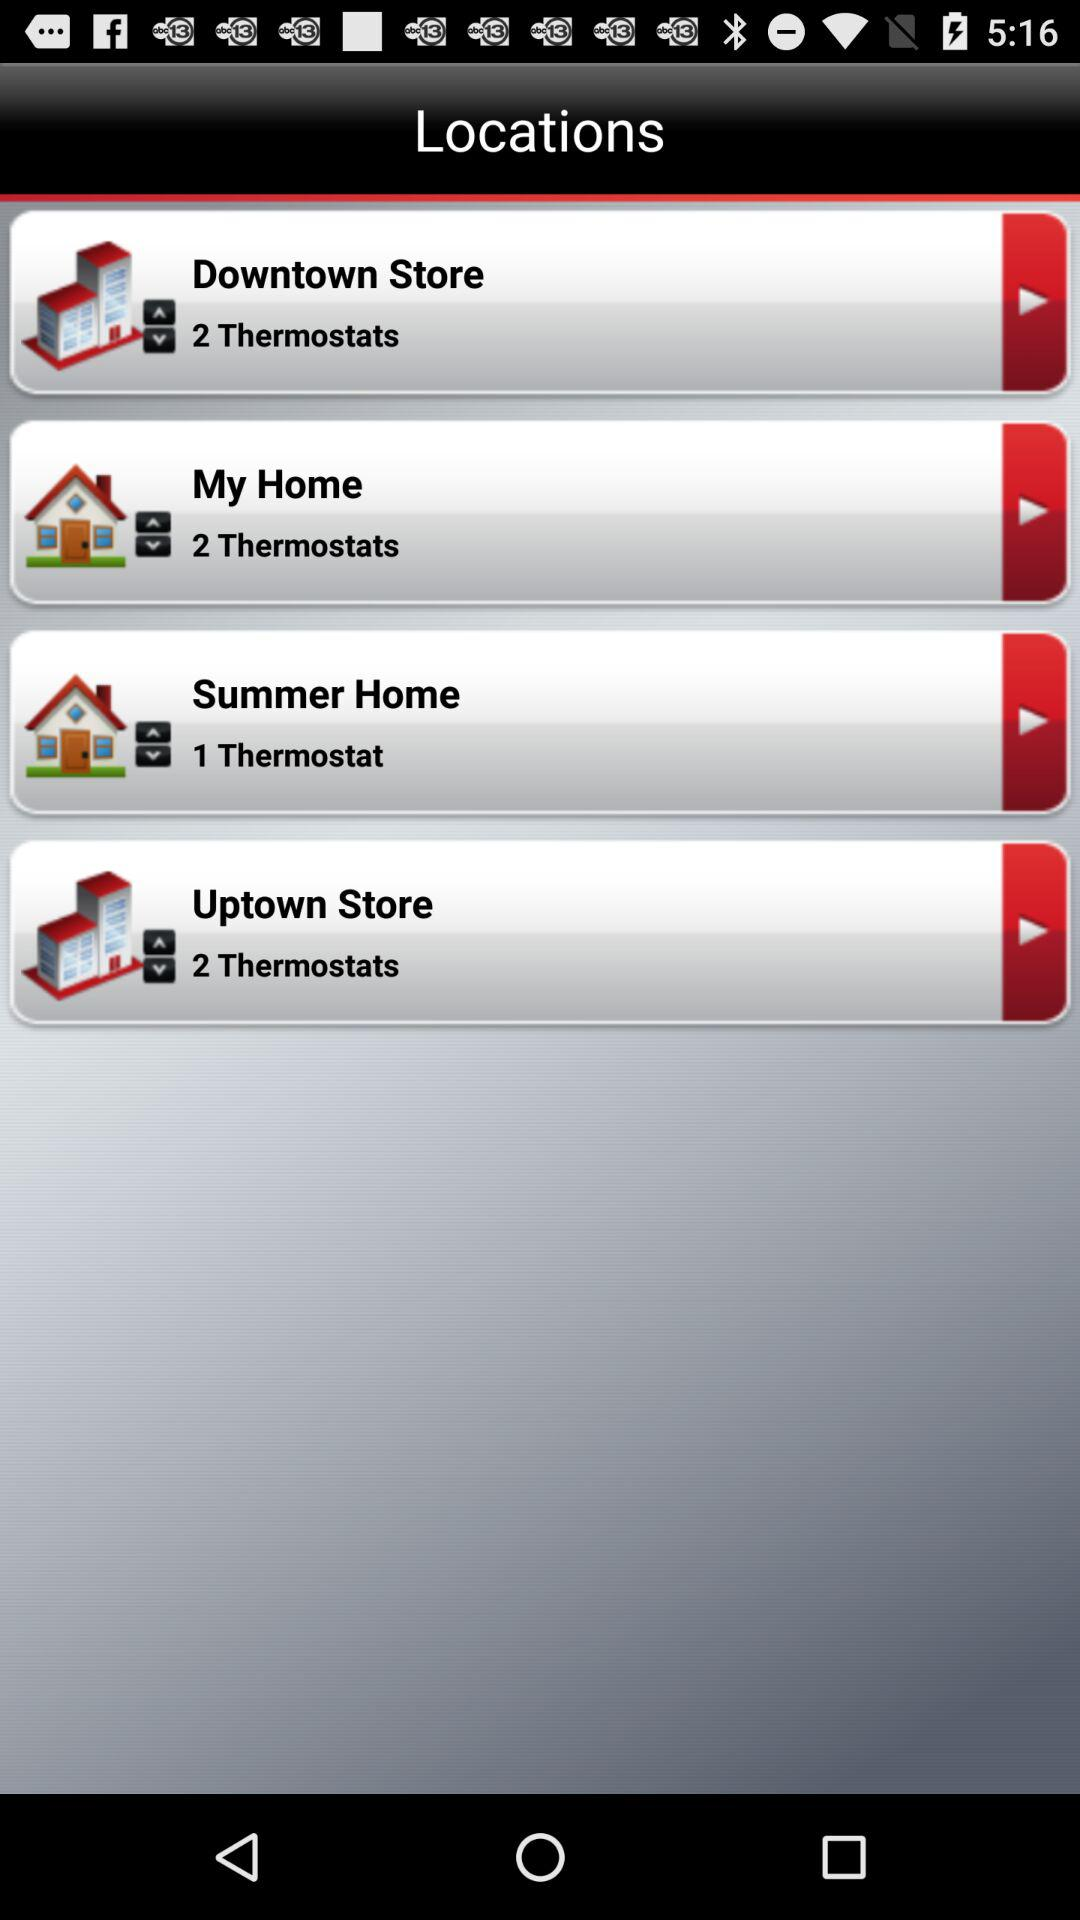How many thermostats are situated in the Uptown Store? There are 2 thermostats situated in the Uptown Store. 